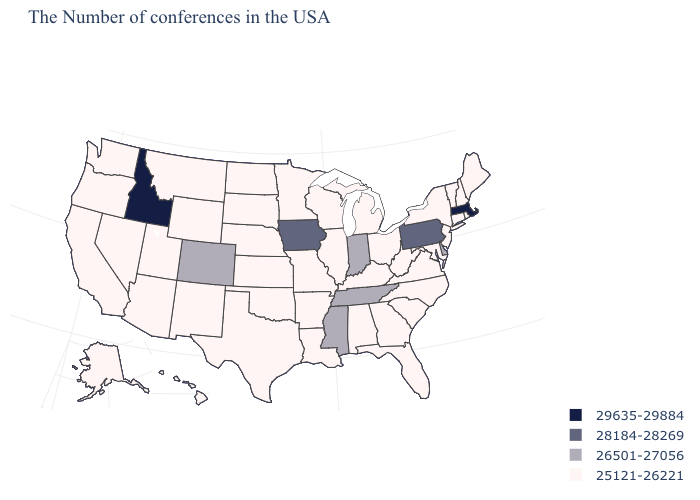Does Delaware have the lowest value in the USA?
Give a very brief answer. No. How many symbols are there in the legend?
Write a very short answer. 4. Among the states that border New York , which have the highest value?
Short answer required. Massachusetts. Name the states that have a value in the range 26501-27056?
Answer briefly. Delaware, Indiana, Tennessee, Mississippi, Colorado. Does Arizona have the same value as Alabama?
Be succinct. Yes. What is the value of Tennessee?
Keep it brief. 26501-27056. Which states have the lowest value in the USA?
Keep it brief. Maine, Rhode Island, New Hampshire, Vermont, Connecticut, New York, New Jersey, Maryland, Virginia, North Carolina, South Carolina, West Virginia, Ohio, Florida, Georgia, Michigan, Kentucky, Alabama, Wisconsin, Illinois, Louisiana, Missouri, Arkansas, Minnesota, Kansas, Nebraska, Oklahoma, Texas, South Dakota, North Dakota, Wyoming, New Mexico, Utah, Montana, Arizona, Nevada, California, Washington, Oregon, Alaska, Hawaii. What is the highest value in the USA?
Short answer required. 29635-29884. Name the states that have a value in the range 29635-29884?
Short answer required. Massachusetts, Idaho. What is the highest value in the USA?
Keep it brief. 29635-29884. Does South Dakota have the lowest value in the USA?
Concise answer only. Yes. Which states hav the highest value in the South?
Answer briefly. Delaware, Tennessee, Mississippi. Does Oklahoma have the highest value in the South?
Be succinct. No. 